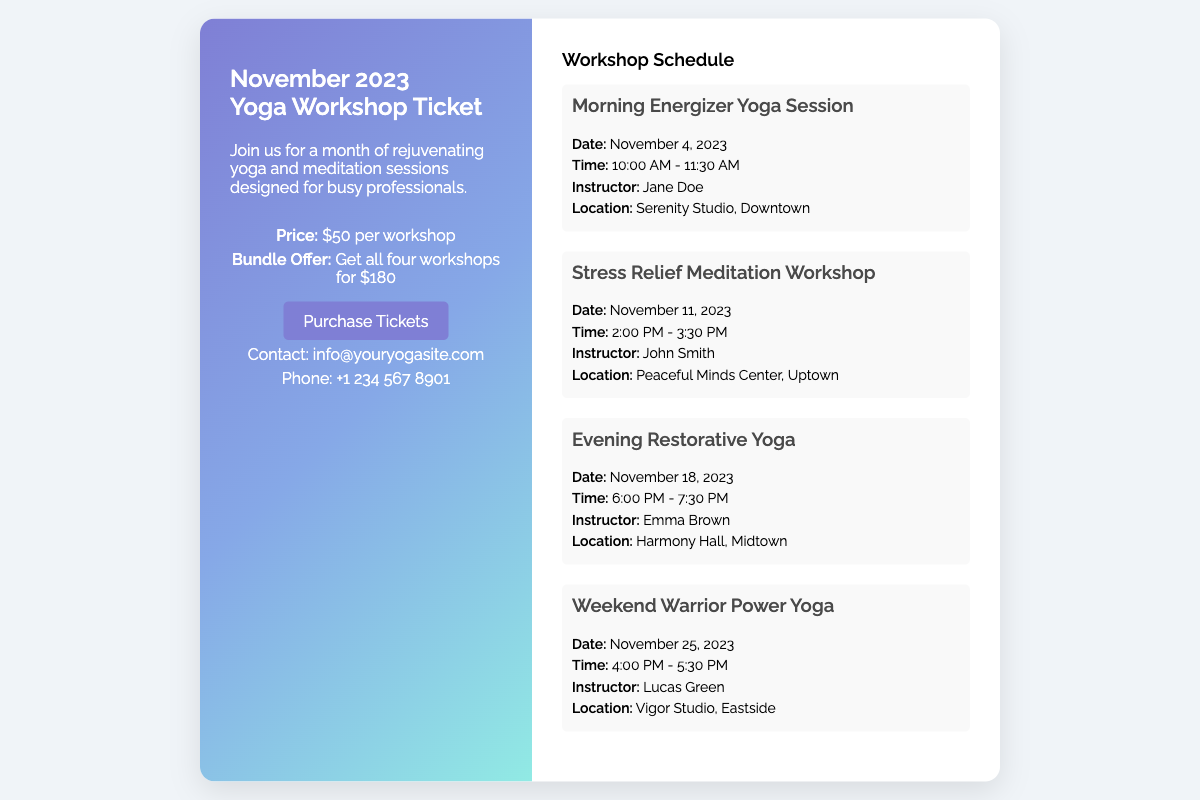What is the title of the workshop? The title of the workshop is "November 2023 Yoga Workshop Ticket."
Answer: November 2023 Yoga Workshop Ticket How much does each workshop cost? The individual workshop price is specified in the document.
Answer: $50 per workshop What is the date of the Morning Energizer Yoga Session? The date for the Morning Energizer Yoga Session is stated in the document.
Answer: November 4, 2023 Who is the instructor for the Stress Relief Meditation Workshop? The instructor's name for the Stress Relief Meditation Workshop can be found in the schedule.
Answer: John Smith What is the location for the Weekend Warrior Power Yoga? The location for the Weekend Warrior Power Yoga is listed in the workshop details.
Answer: Vigor Studio, Eastside How long is the Evening Restorative Yoga session? The duration of the Evening Restorative Yoga session can be calculated based on the start and end times.
Answer: 1 hour 30 minutes What is the total cost for all four workshops? The total cost for the bundle provided in the ticket information.
Answer: $180 What is the time for the Afternoon Stress Relief Meditation Workshop? The time for the Stress Relief Meditation Workshop is clearly provided in the document.
Answer: 2:00 PM - 3:30 PM 